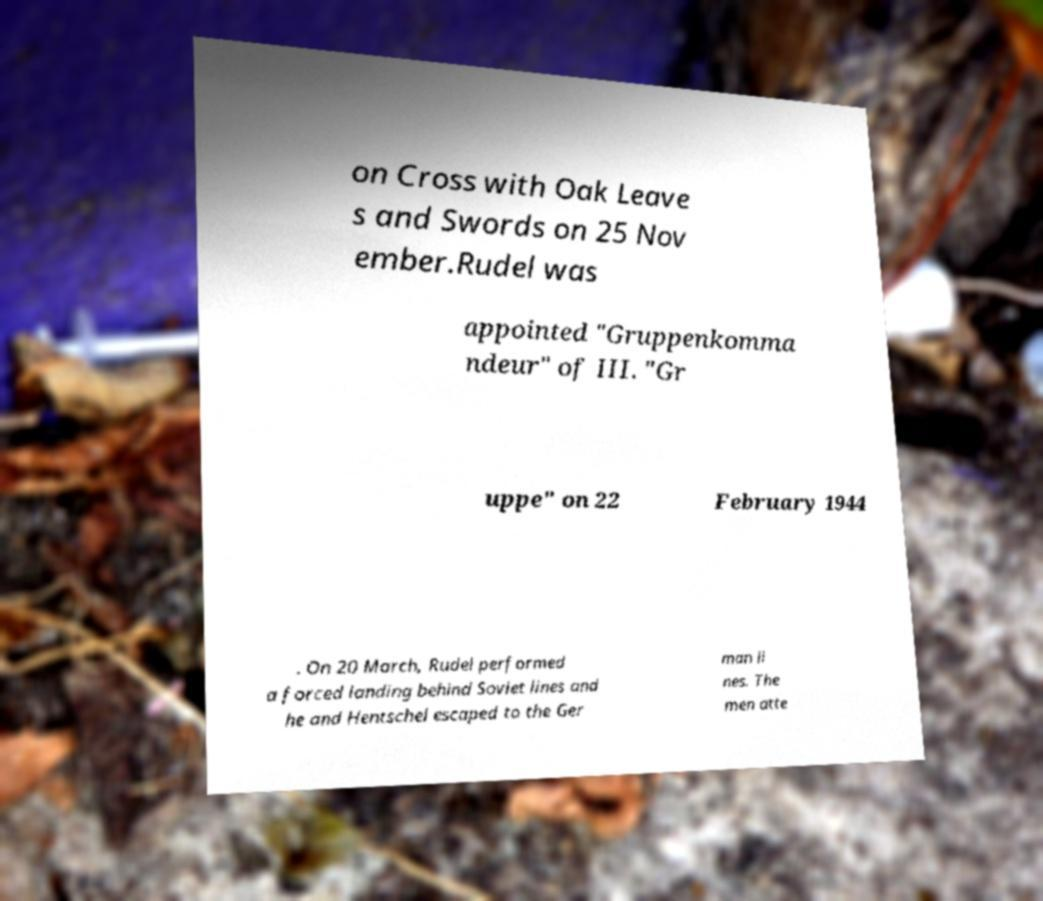Could you extract and type out the text from this image? on Cross with Oak Leave s and Swords on 25 Nov ember.Rudel was appointed "Gruppenkomma ndeur" of III. "Gr uppe" on 22 February 1944 . On 20 March, Rudel performed a forced landing behind Soviet lines and he and Hentschel escaped to the Ger man li nes. The men atte 